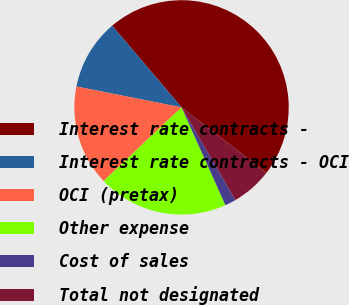<chart> <loc_0><loc_0><loc_500><loc_500><pie_chart><fcel>Interest rate contracts -<fcel>Interest rate contracts - OCI<fcel>OCI (pretax)<fcel>Other expense<fcel>Cost of sales<fcel>Total not designated<nl><fcel>46.66%<fcel>10.67%<fcel>15.17%<fcel>19.67%<fcel>1.67%<fcel>6.17%<nl></chart> 